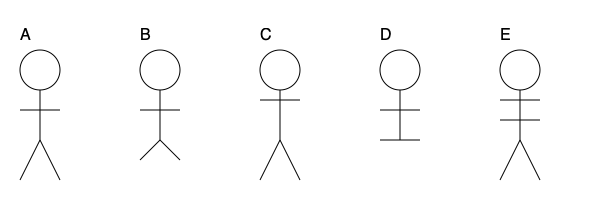Identify the correct sequence of steps in the traditional Polynesian 'Ote'a dance based on the movement diagrams provided. Which order represents the proper progression of the dance? To determine the correct sequence of steps in the 'Ote'a dance, we need to analyze each diagram and understand the progression of movements:

1. Diagram A: This shows the basic standing position with arms outstretched, typically the starting pose.

2. Diagram C: The arms are raised higher, indicating the next movement where dancers lift their arms above their shoulders.

3. Diagram E: Two horizontal lines across the body suggest rapid arm movements, characteristic of the 'Ote'a's energetic style.

4. Diagram B: The legs are slightly bent, implying a lowering of the body, often preceding a more dramatic movement.

5. Diagram D: The straight horizontal line at the bottom suggests a final pose, with arms outstretched and legs together.

The 'Ote'a dance typically begins with slower, controlled movements and progresses to more energetic ones before concluding. This sequence (A-C-E-B-D) follows this pattern, starting with basic poses, moving through more dynamic movements, and ending in a defined final position.
Answer: A-C-E-B-D 